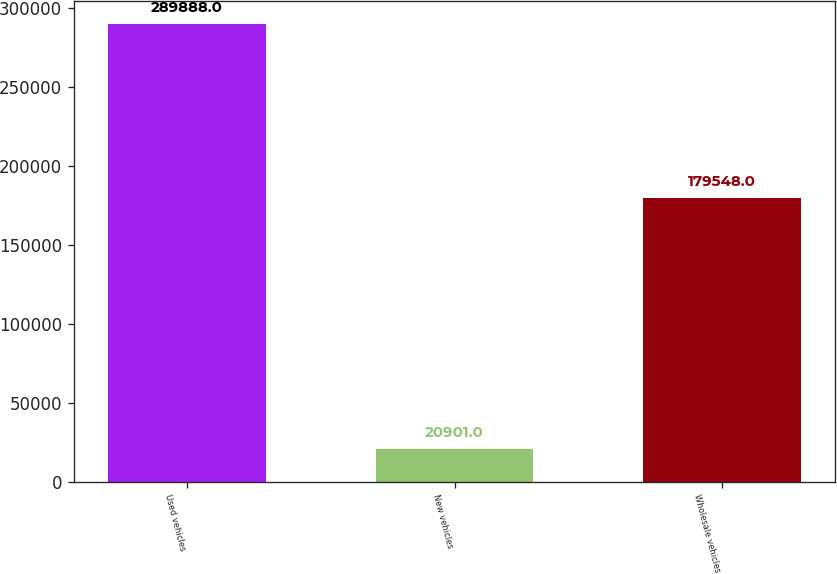Convert chart to OTSL. <chart><loc_0><loc_0><loc_500><loc_500><bar_chart><fcel>Used vehicles<fcel>New vehicles<fcel>Wholesale vehicles<nl><fcel>289888<fcel>20901<fcel>179548<nl></chart> 